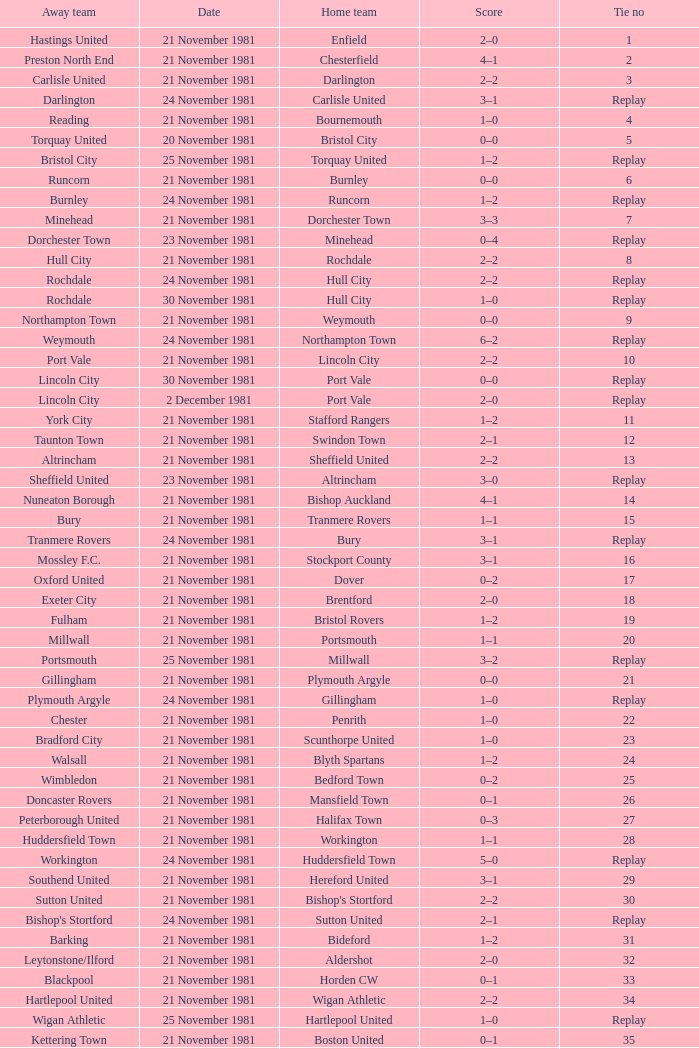Minehead has what tie number? Replay. 